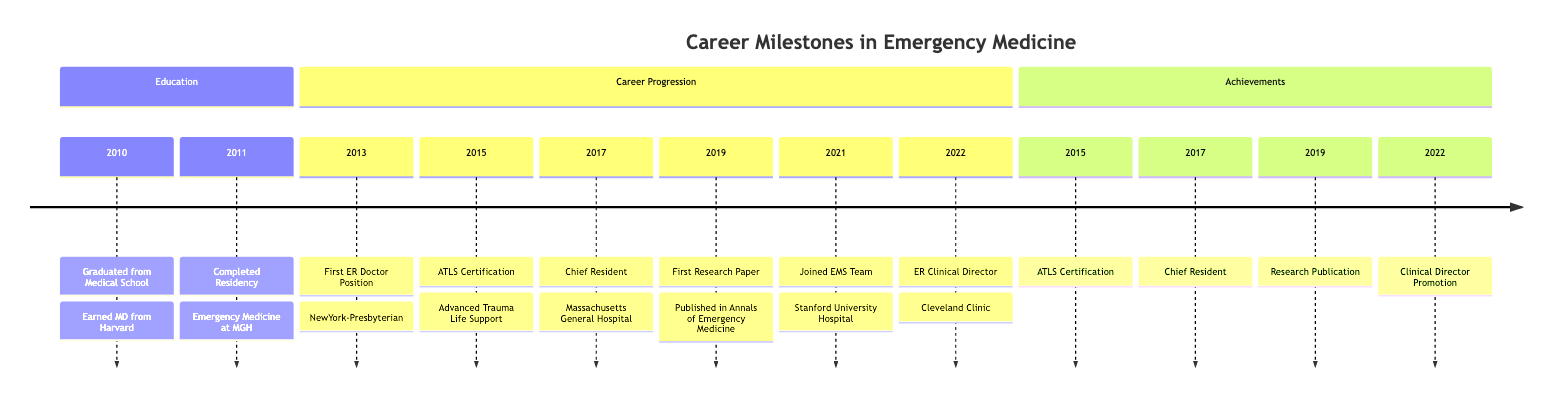What year did you graduate from medical school? The diagram indicates that the event "Graduated from Medical School" occurred in the year 2010.
Answer: 2010 What position did you hold in 2017? In 2017, the diagram shows that the event was "Became Chief Resident in Emergency Medicine."
Answer: Chief Resident How many milestones are listed in the Career Progression section? The Career Progression section includes 6 events: First ER Doctor Position, ATLS Certification, Chief Resident, First Research Paper, Joined EMS Team, and ER Clinical Director.
Answer: 6 What certification did you receive in 2015? The diagram notes that in 2015, you received "Advanced Trauma Life Support" certification.
Answer: Advanced Trauma Life Support What was the focus of your first research paper? According to the diagram, the focus was on "Effective Strategies for Managing Acute Respiratory Distress in Emergency Settings."
Answer: Managing Acute Respiratory Distress Which hospital did you join for your first ER doctor position? The timeline specifies that you started your first ER doctor position at "NewYork-Presbyterian/Weill Cornell Medical Center."
Answer: NewYork-Presbyterian/Weill Cornell Medical Center What is the latest milestone mentioned in the timeline? The most recent event listed is "Promoted to ER Clinical Director" in the year 2022.
Answer: Promoted to ER Clinical Director How many achievements are highlighted in the Achievements section? The Achievements section highlights 4 specific milestones: ATLS Certification, Chief Resident, Research Publication, and Clinical Director Promotion.
Answer: 4 What relationship can be inferred between becoming a Chief Resident and publishing your first research paper? Both events demonstrate advancements in your career: the Chief Resident role likely provided experience and authority that contributed to your ability to conduct research published in a prestigious medical journal.
Answer: Career advancement relationship 